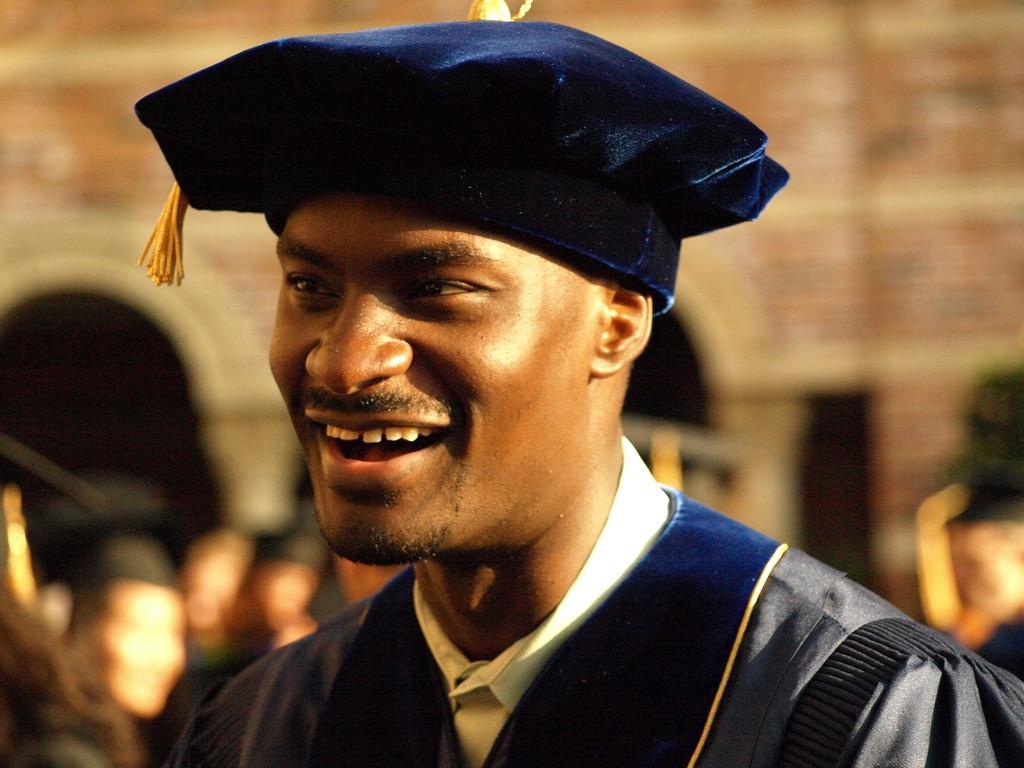In one or two sentences, can you explain what this image depicts? In this image I can see the person wearing the blue and white color dress and also the hat. The person is smiling. In the back I can see few more people and the building but it is blurry. 